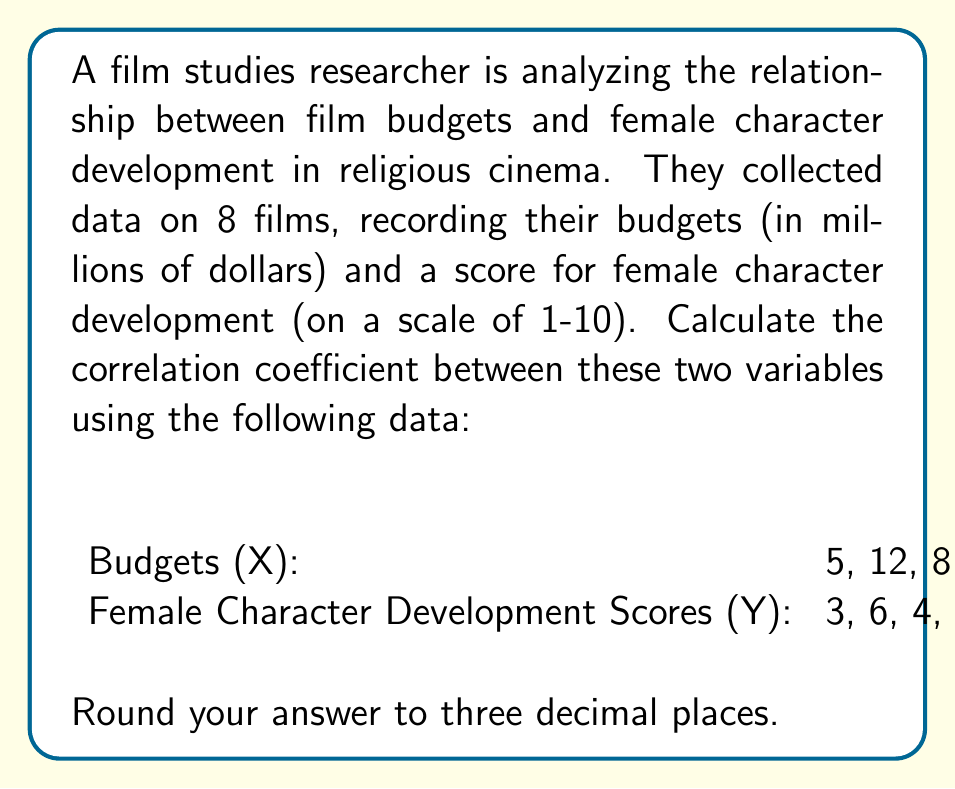Solve this math problem. To calculate the correlation coefficient (r), we'll use the formula:

$$ r = \frac{n\sum xy - \sum x \sum y}{\sqrt{[n\sum x^2 - (\sum x)^2][n\sum y^2 - (\sum y)^2]}} $$

Where n is the number of data points.

Step 1: Calculate the sums and squared sums:
$\sum x = 95$
$\sum y = 46$
$\sum x^2 = 1,499$
$\sum y^2 = 278$
$\sum xy = 601$

Step 2: Calculate $n\sum xy$ and $\sum x \sum y$:
$n\sum xy = 8 * 601 = 4,808$
$\sum x \sum y = 95 * 46 = 4,370$

Step 3: Calculate the numerator:
$n\sum xy - \sum x \sum y = 4,808 - 4,370 = 438$

Step 4: Calculate the parts of the denominator:
$n\sum x^2 - (\sum x)^2 = 8 * 1,499 - 95^2 = 11,992 - 9,025 = 2,967$
$n\sum y^2 - (\sum y)^2 = 8 * 278 - 46^2 = 2,224 - 2,116 = 108$

Step 5: Calculate the denominator:
$\sqrt{[n\sum x^2 - (\sum x)^2][n\sum y^2 - (\sum y)^2]} = \sqrt{2,967 * 108} = \sqrt{320,436} \approx 565.89$

Step 6: Divide the numerator by the denominator:
$r = \frac{438}{565.89} \approx 0.774$

Step 7: Round to three decimal places:
$r \approx 0.774$
Answer: 0.774 